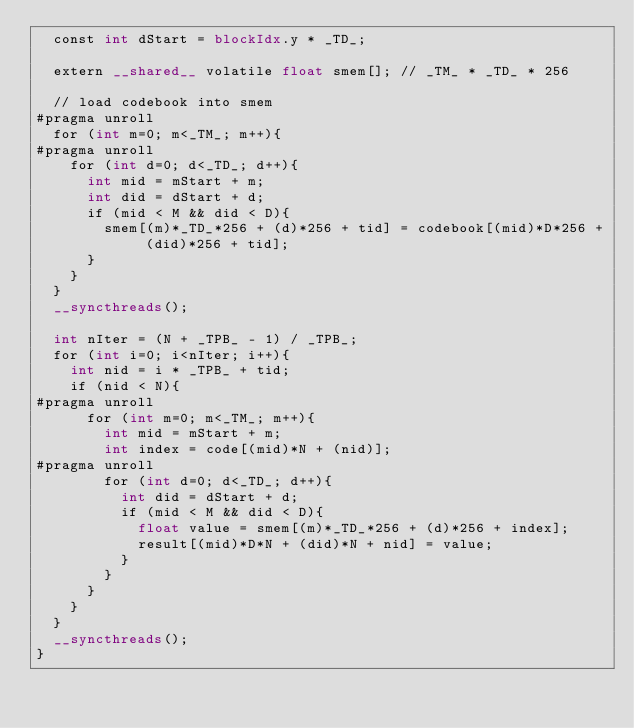Convert code to text. <code><loc_0><loc_0><loc_500><loc_500><_Cuda_>  const int dStart = blockIdx.y * _TD_;

  extern __shared__ volatile float smem[]; // _TM_ * _TD_ * 256

  // load codebook into smem
#pragma unroll
  for (int m=0; m<_TM_; m++){
#pragma unroll
    for (int d=0; d<_TD_; d++){
      int mid = mStart + m;
      int did = dStart + d;
      if (mid < M && did < D){
        smem[(m)*_TD_*256 + (d)*256 + tid] = codebook[(mid)*D*256 + (did)*256 + tid];
      }
    }
  }
  __syncthreads();

  int nIter = (N + _TPB_ - 1) / _TPB_;
  for (int i=0; i<nIter; i++){
    int nid = i * _TPB_ + tid;
    if (nid < N){
#pragma unroll
      for (int m=0; m<_TM_; m++){
        int mid = mStart + m;
        int index = code[(mid)*N + (nid)];
#pragma unroll
        for (int d=0; d<_TD_; d++){
          int did = dStart + d;
          if (mid < M && did < D){
            float value = smem[(m)*_TD_*256 + (d)*256 + index];
            result[(mid)*D*N + (did)*N + nid] = value;
          }
        }
      }
    }
  }
  __syncthreads();
}</code> 